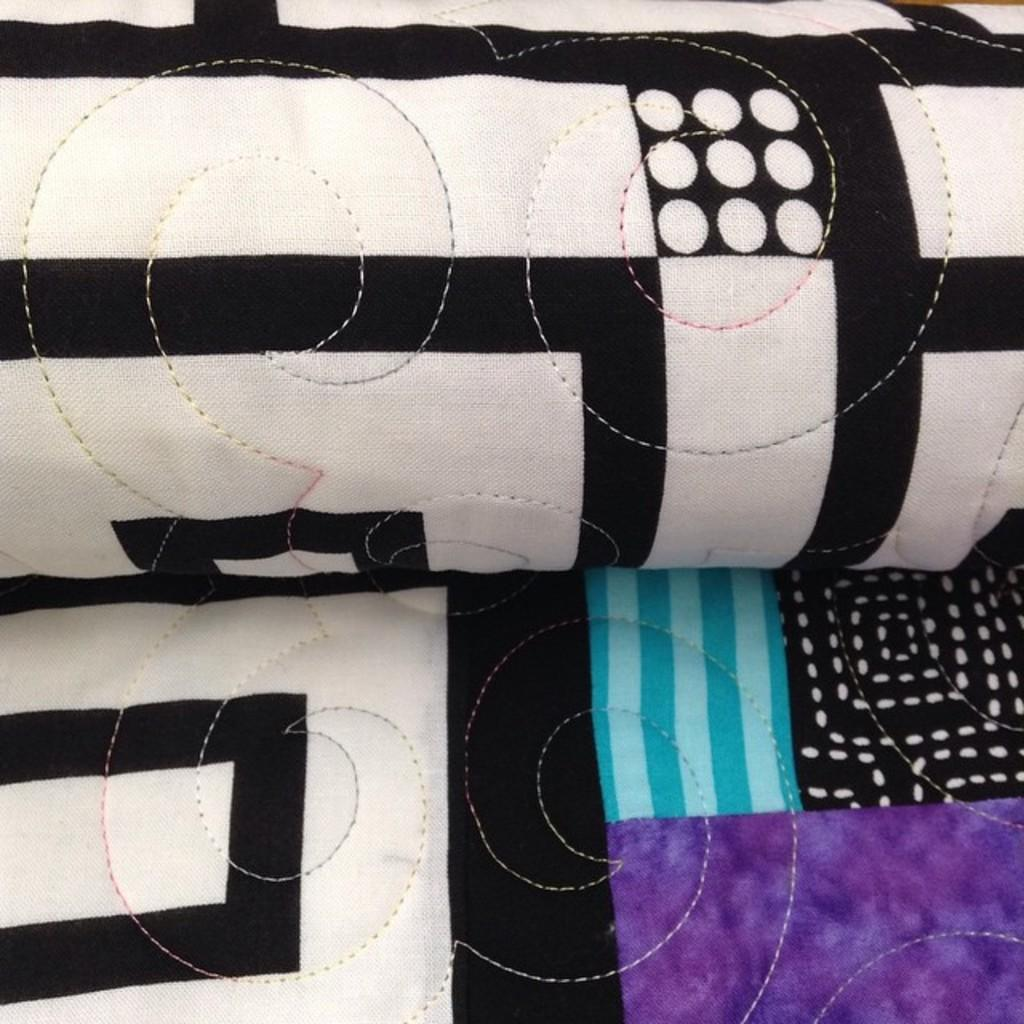What type of material is present in the image? There is cloth of different colors in the image. Can you describe the colors of the cloth? The cloth in the image has different colors. What might the cloth be used for? The cloth could be used for various purposes, such as clothing, decoration, or upholstery. Who has the authority to lead the feast in the image? There is no feast or authority figure present in the image; it only features cloth of different colors. 